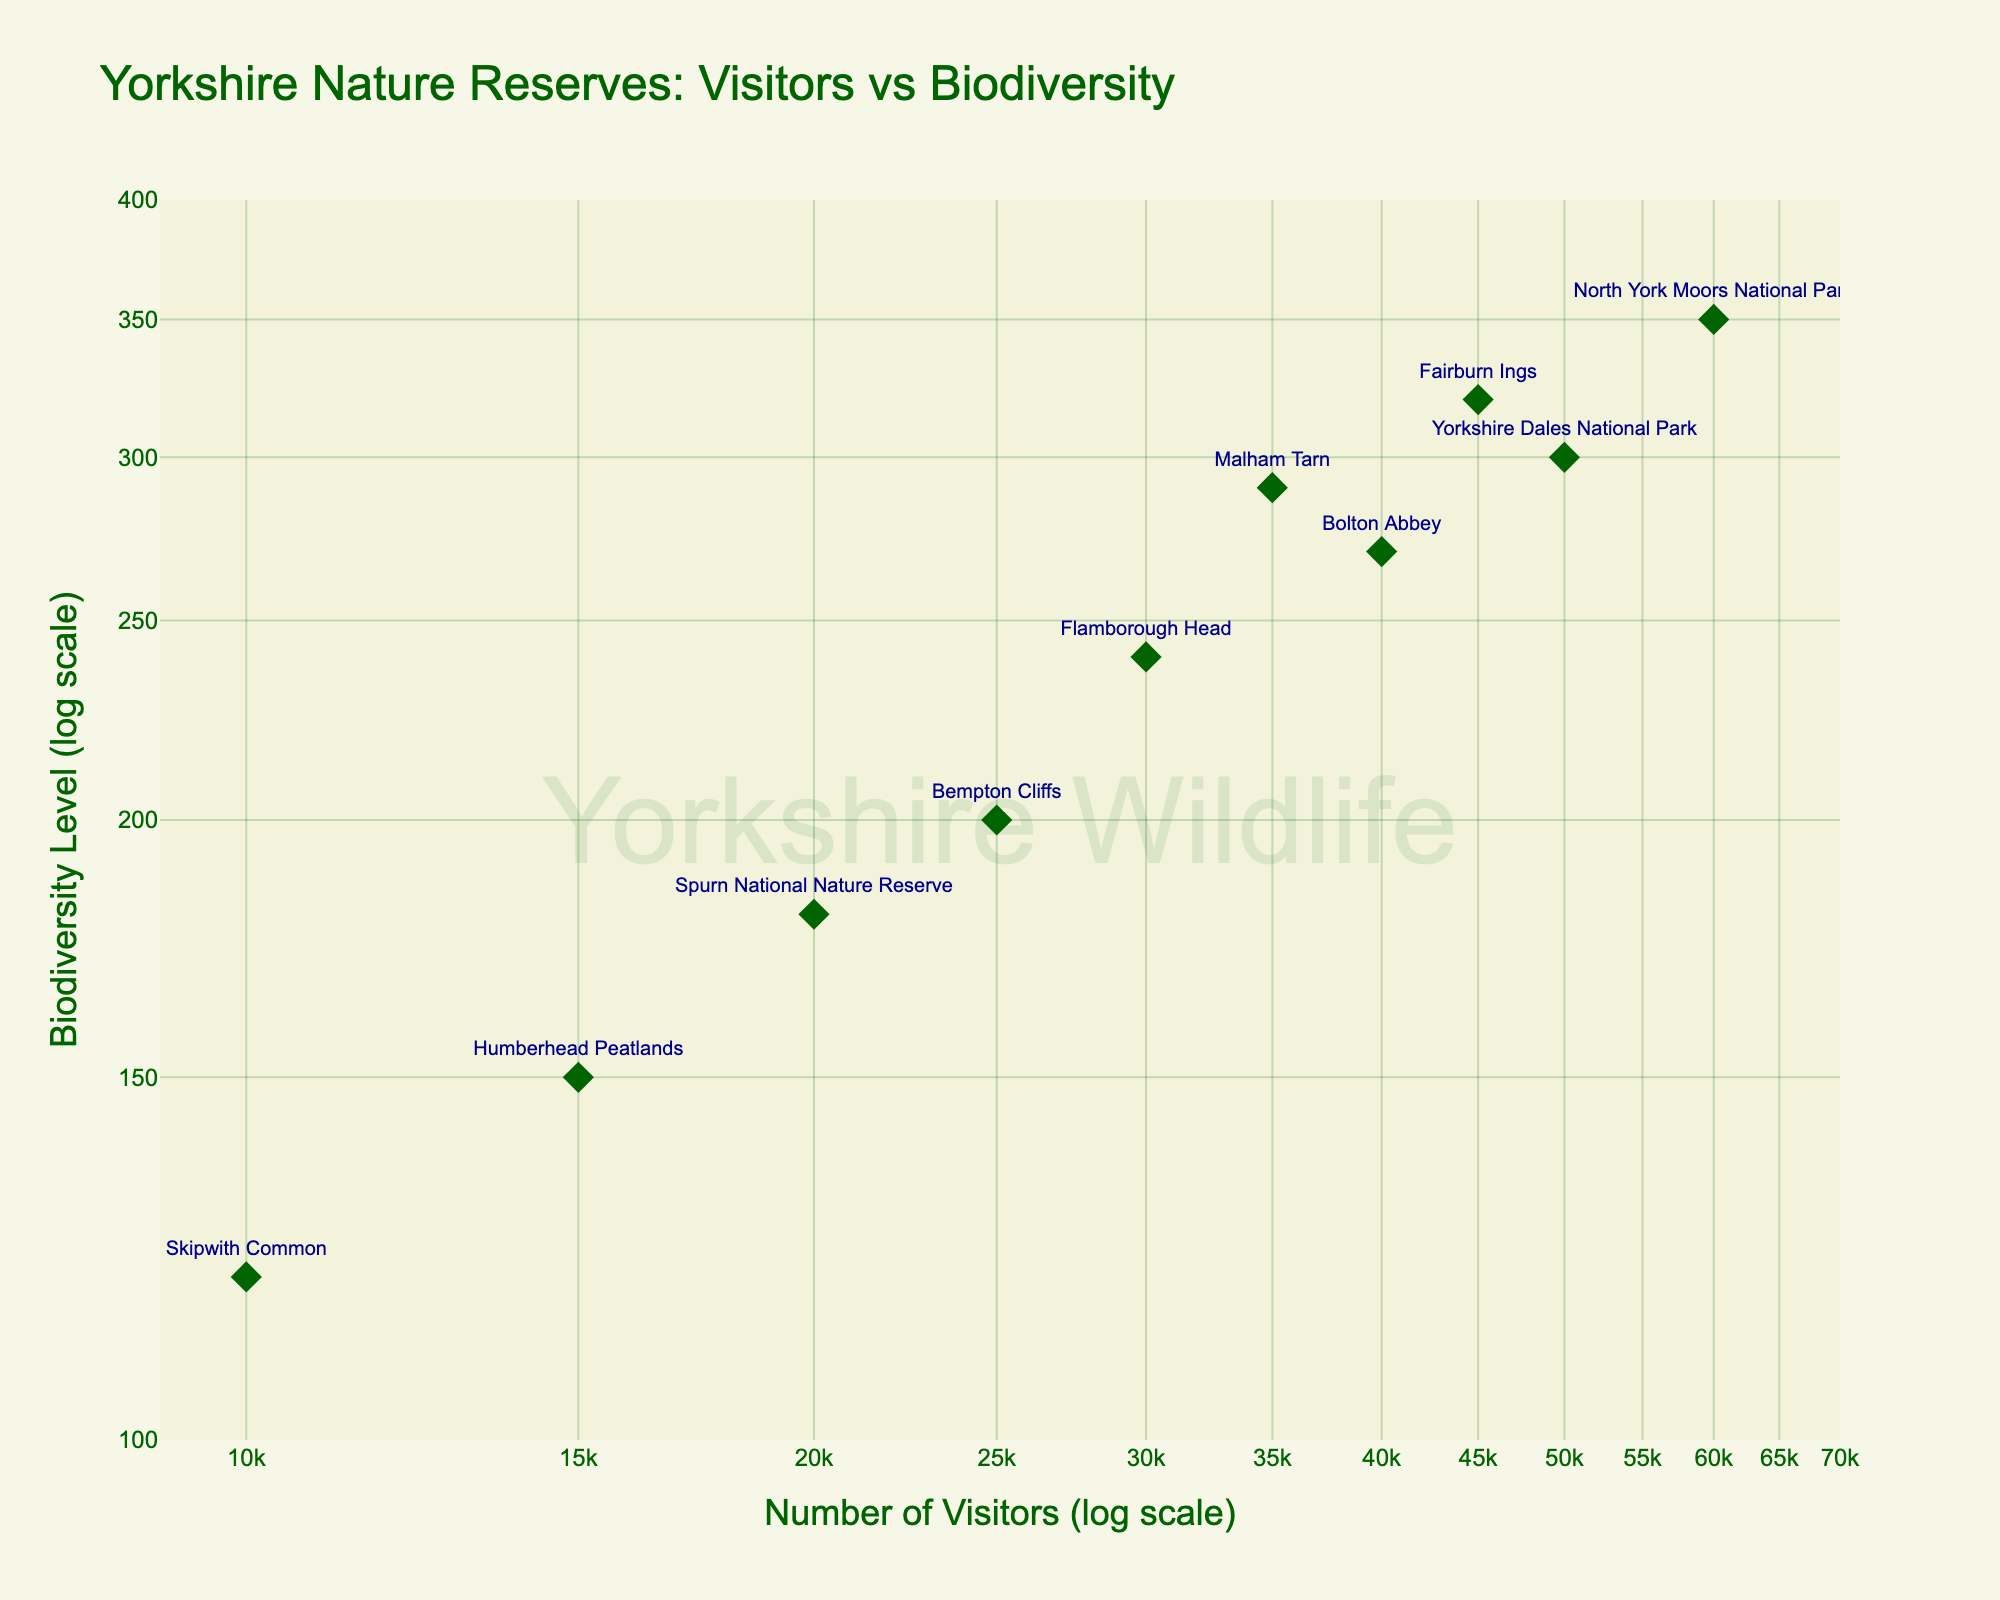How many nature reserves are plotted in the figure? By counting the number of distinct data points or labels on the scatter plot, you can see there are 10 nature reserves plotted.
Answer: 10 What is the title of the figure? The title is usually displayed at the top of the figure and in this case, it is "Yorkshire Nature Reserves: Visitors vs Biodiversity".
Answer: Yorkshire Nature Reserves: Visitors vs Biodiversity Which nature reserve has the highest number of visitors? By looking at the x-axis, which shows the number of visitors, the point furthest to the right represents the North York Moors National Park, which has the highest number of visitors.
Answer: North York Moors National Park Which nature reserve has the lowest biodiversity level? By examining the y-axis for the biodiversity level and finding the point closest to the bottom, we see that Skipwith Common has the lowest biodiversity level.
Answer: Skipwith Common Which reserve has the highest biodiversity level among those with fewer than 30,000 visitors? First, identify the reserves with fewer than 30,000 visitors by locating the points to the left of the 30,000 mark on the x-axis. The reserve with the highest biodiversity level among these is Bempton Cliffs.
Answer: Bempton Cliffs What is the range of the biodiversity levels plotted? The range can be found by identifying the highest and lowest points on the y-axis. The highest biodiversity level is around 350 (North York Moors National Park) and the lowest is around 120 (Skipwith Common), giving a range of 120 to 350.
Answer: 120 to 350 Compare the number of visitors between Bempton Cliffs and Flamborough Head. Which has more visitors, and by how much? Bempton Cliffs has 25,000 visitors and Flamborough Head has 30,000 visitors. Flamborough Head has more visitors by 5,000.
Answer: Flamborough Head, 5,000 more Which reserve has the closest number of visitors and biodiversity? By looking at the plot, Fairburn Ings has about 45,000 visitors and 320 biodiversity levels, making these numbers relatively close compared to other reserves.
Answer: Fairburn Ings What is the average number of visitors for reserves with biodiversity levels between 200 and 300? Identify reserves with biodiversity levels in the range [200, 300]: Bempton Cliffs (25,000), Spurn National Nature Reserve (20,000), Bolton Abbey (40,000), Malham Tarn (35,000). The average number of visitors is:
(25,000 + 20,000 + 40,000 + 35,000) / 4 = 30,000
Answer: 30,000 